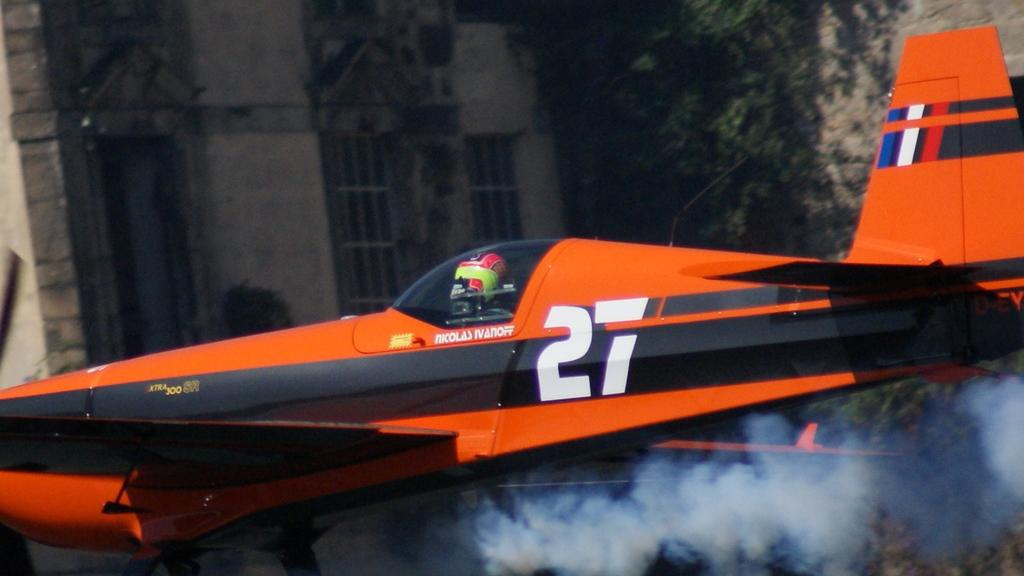<image>
Write a terse but informative summary of the picture. A red airplane has the number 27 on the side. 